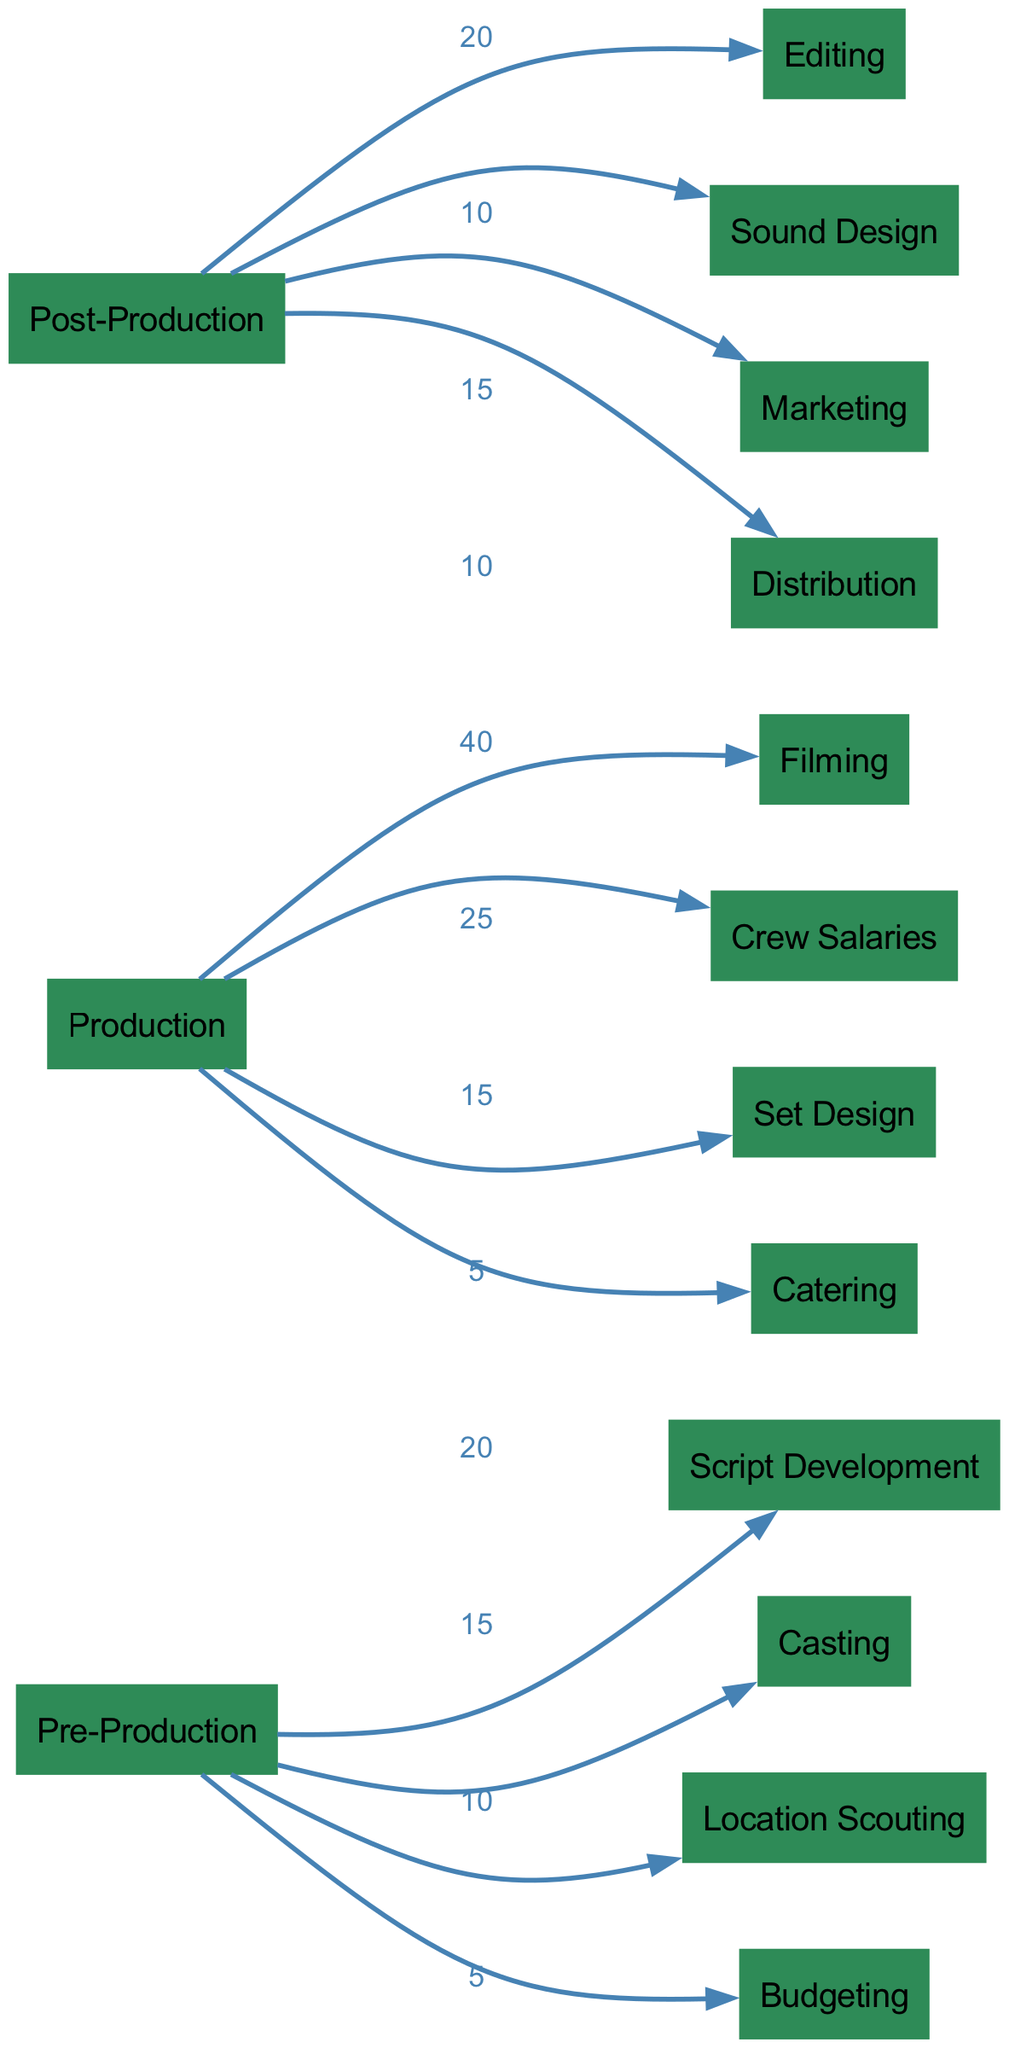What is the total budget allocation for Pre-Production? The diagram shows values associated with each task under Pre-Production: 20 for Script Development, 15 for Casting, 10 for Location Scouting, and 5 for Budgeting. Adding these values gives a total of 20 + 15 + 10 + 5 = 50.
Answer: 50 Which element receives the highest budget in Production? The diagram indicates that under Production, Filming has an allocation of 40, which is higher than the allocated budgets for Crew Salaries (25), Set Design (15), and Catering (5). Therefore, Filming is the highest.
Answer: Filming How many nodes are there in total? The diagram lists a total of 15 different nodes, each representing a different aspect of film production and budget allocation. Counting each node provided in the data confirms there are 15.
Answer: 15 What are the total costs allocated to Post-Production? In the diagram, total costs for Post-Production can be calculated by summing the individual allocations: 20 for Editing, 10 for Sound Design, 15 for Marketing, and 10 for Distribution, resulting in 20 + 10 + 15 + 10 = 55.
Answer: 55 What is the relationship between Production and Filming? The diagram shows that Production flows into Filming with a budget allocation value of 40, indicating that this is the amount assigned specifically for the Filming segment within the overall Production stage.
Answer: 40 